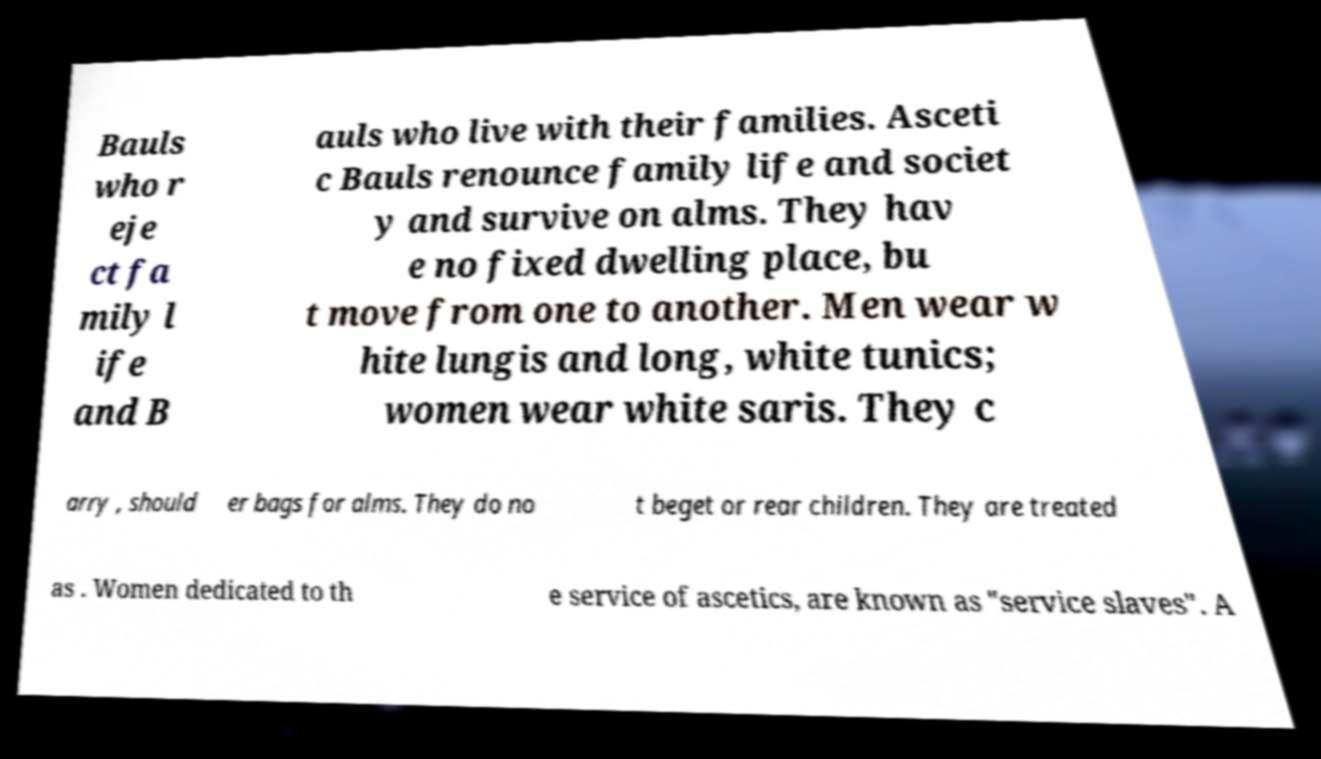Can you accurately transcribe the text from the provided image for me? Bauls who r eje ct fa mily l ife and B auls who live with their families. Asceti c Bauls renounce family life and societ y and survive on alms. They hav e no fixed dwelling place, bu t move from one to another. Men wear w hite lungis and long, white tunics; women wear white saris. They c arry , should er bags for alms. They do no t beget or rear children. They are treated as . Women dedicated to th e service of ascetics, are known as "service slaves". A 